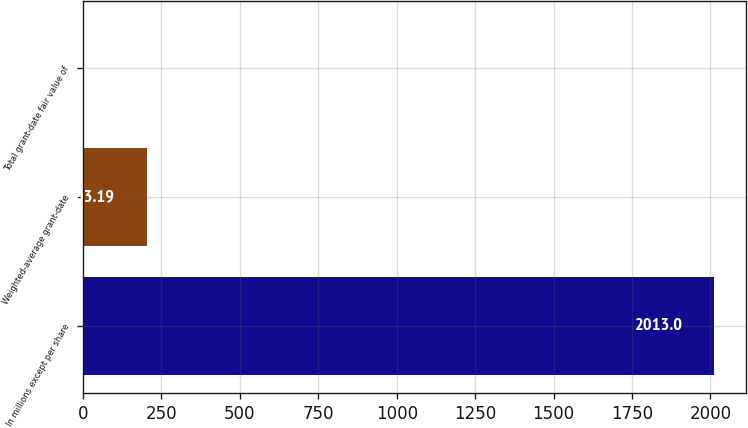Convert chart. <chart><loc_0><loc_0><loc_500><loc_500><bar_chart><fcel>In millions except per share<fcel>Weighted-average grant-date<fcel>Total grant-date fair value of<nl><fcel>2013<fcel>203.19<fcel>2.1<nl></chart> 